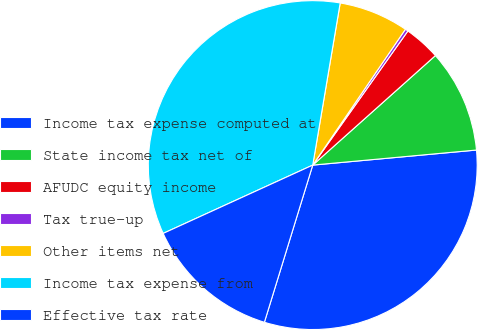<chart> <loc_0><loc_0><loc_500><loc_500><pie_chart><fcel>Income tax expense computed at<fcel>State income tax net of<fcel>AFUDC equity income<fcel>Tax true-up<fcel>Other items net<fcel>Income tax expense from<fcel>Effective tax rate<nl><fcel>31.21%<fcel>10.14%<fcel>3.58%<fcel>0.29%<fcel>6.86%<fcel>34.49%<fcel>13.43%<nl></chart> 